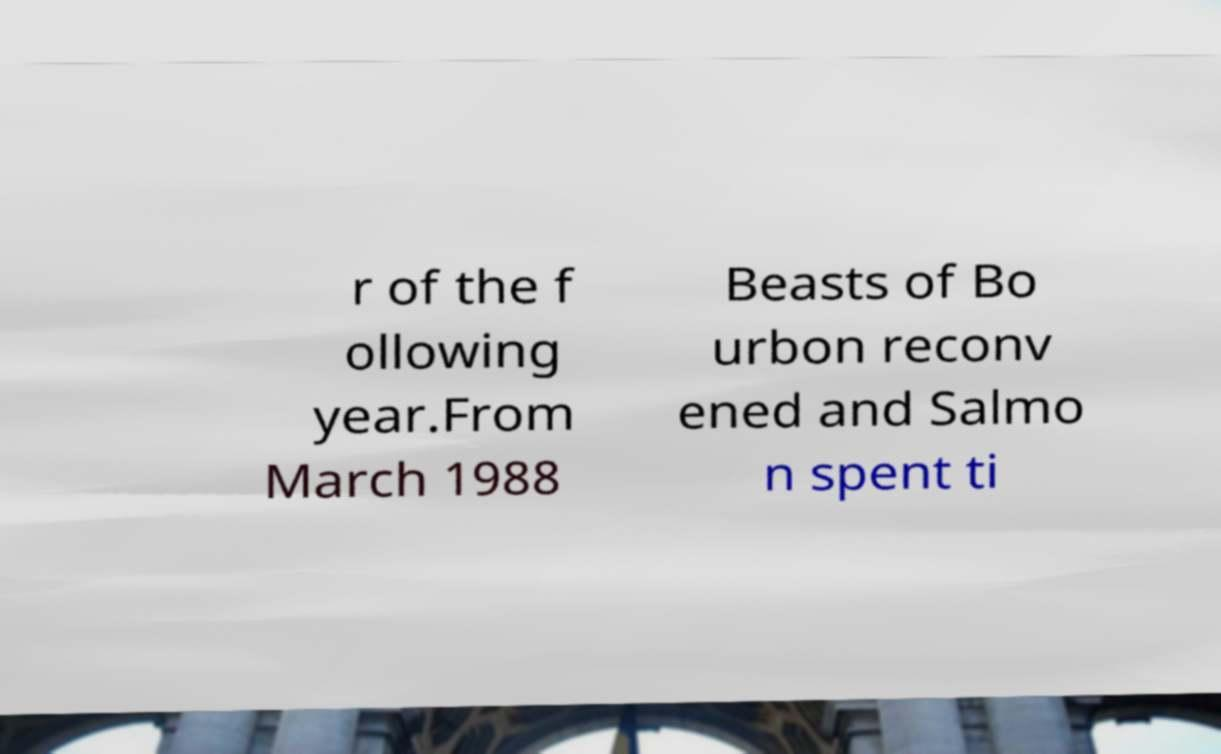Could you assist in decoding the text presented in this image and type it out clearly? r of the f ollowing year.From March 1988 Beasts of Bo urbon reconv ened and Salmo n spent ti 